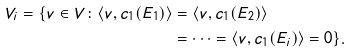<formula> <loc_0><loc_0><loc_500><loc_500>V _ { i } = \{ v \in V \colon \langle v , c _ { 1 } ( E _ { 1 } ) \rangle & = \langle v , c _ { 1 } ( E _ { 2 } ) \rangle \\ & = \dots = \langle v , c _ { 1 } ( E _ { i } ) \rangle = 0 \} .</formula> 